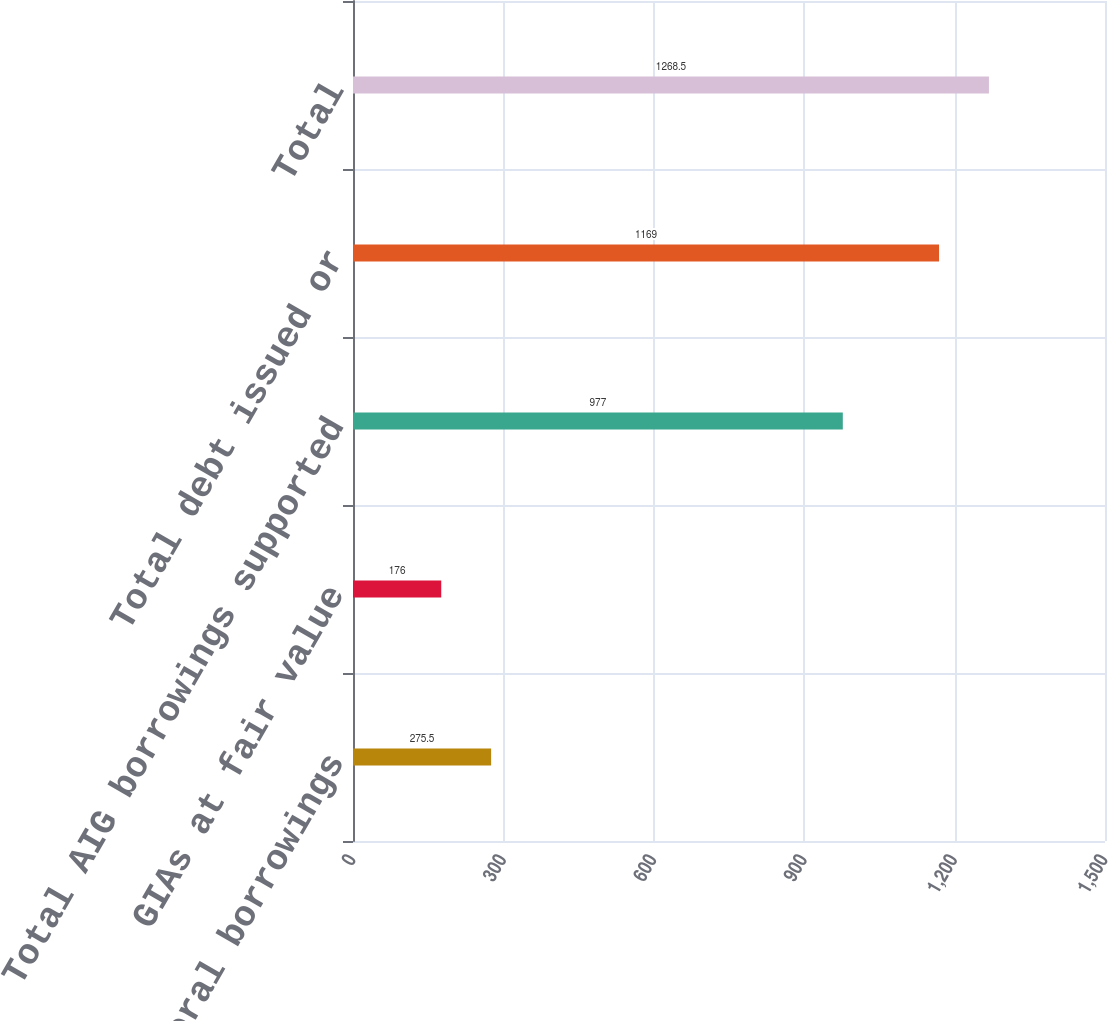Convert chart to OTSL. <chart><loc_0><loc_0><loc_500><loc_500><bar_chart><fcel>Total AIG general borrowings<fcel>GIAs at fair value<fcel>Total AIG borrowings supported<fcel>Total debt issued or<fcel>Total<nl><fcel>275.5<fcel>176<fcel>977<fcel>1169<fcel>1268.5<nl></chart> 